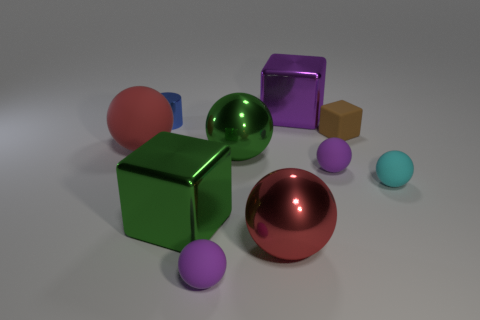Subtract 1 cubes. How many cubes are left? 2 Subtract all red balls. How many balls are left? 4 Subtract all small cyan matte balls. How many balls are left? 5 Subtract all brown balls. Subtract all cyan cylinders. How many balls are left? 6 Subtract all balls. How many objects are left? 4 Subtract all green objects. Subtract all cyan objects. How many objects are left? 7 Add 6 large metallic spheres. How many large metallic spheres are left? 8 Add 3 yellow balls. How many yellow balls exist? 3 Subtract 1 green blocks. How many objects are left? 9 